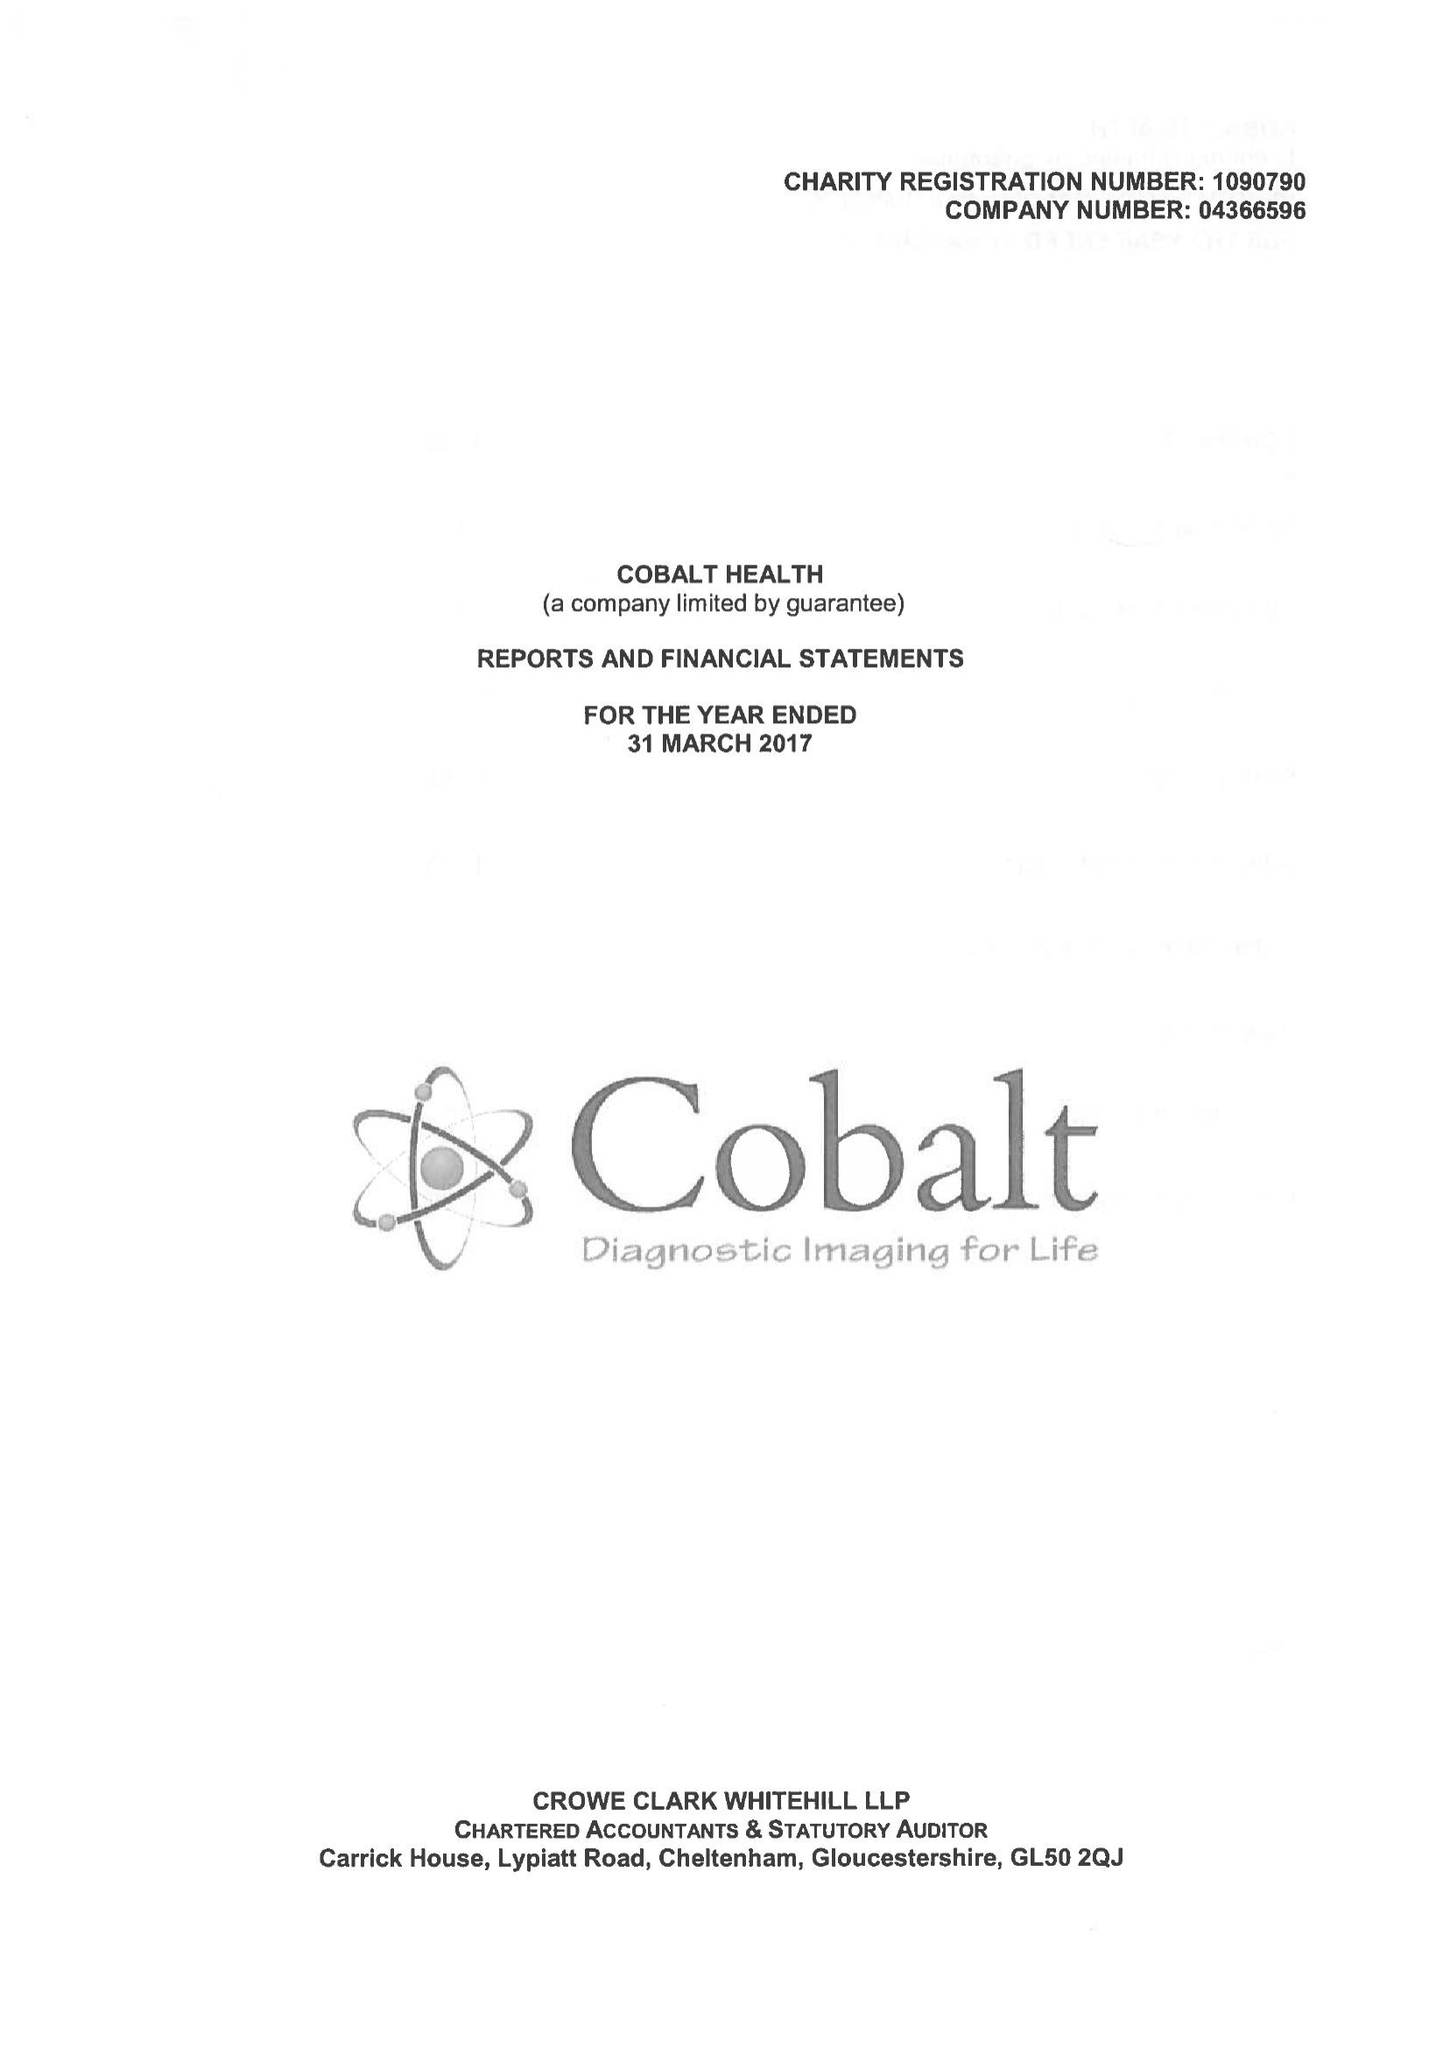What is the value for the charity_number?
Answer the question using a single word or phrase. 1090790 